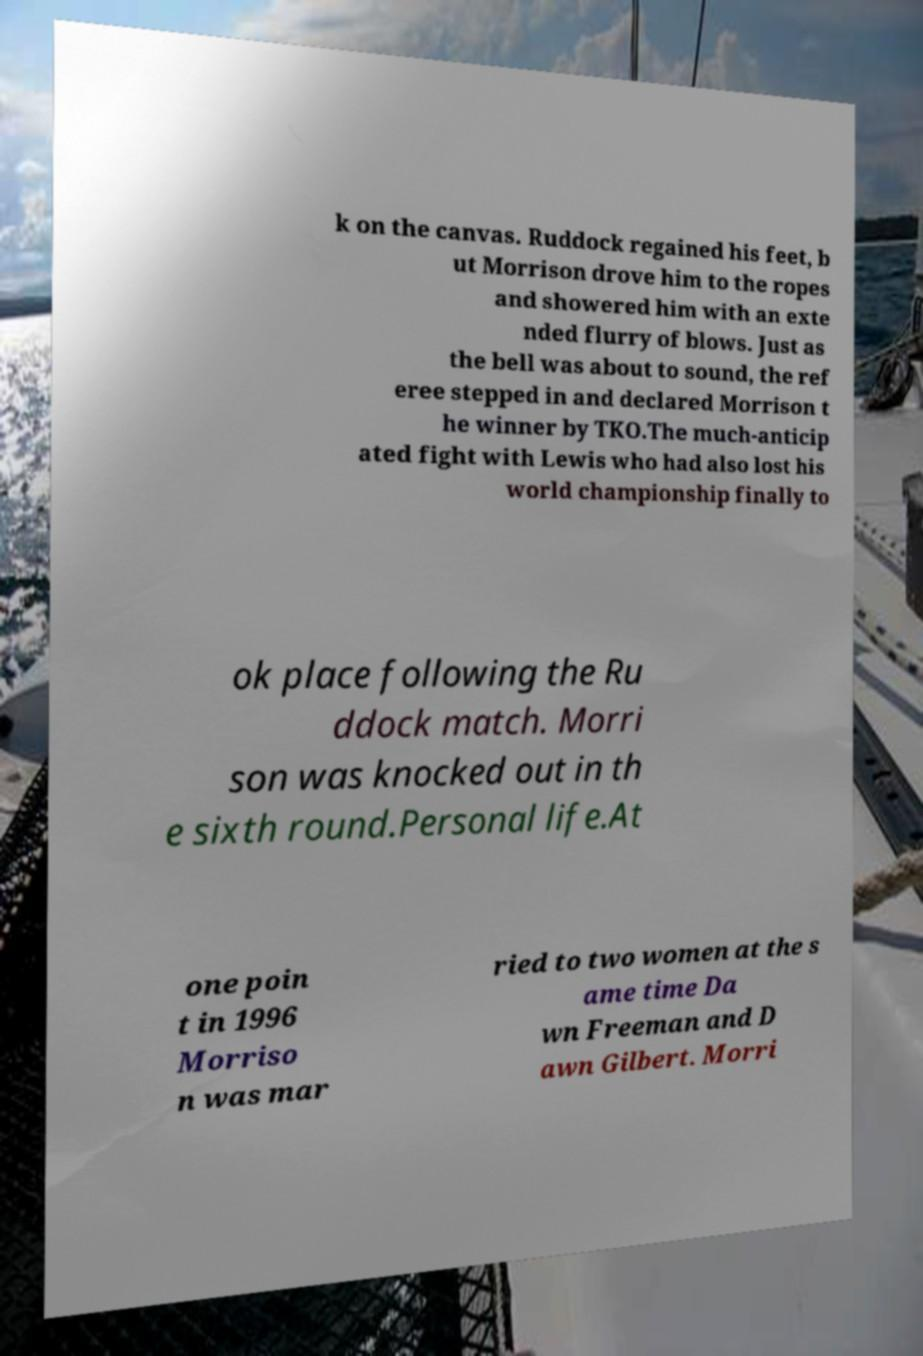Please identify and transcribe the text found in this image. k on the canvas. Ruddock regained his feet, b ut Morrison drove him to the ropes and showered him with an exte nded flurry of blows. Just as the bell was about to sound, the ref eree stepped in and declared Morrison t he winner by TKO.The much-anticip ated fight with Lewis who had also lost his world championship finally to ok place following the Ru ddock match. Morri son was knocked out in th e sixth round.Personal life.At one poin t in 1996 Morriso n was mar ried to two women at the s ame time Da wn Freeman and D awn Gilbert. Morri 